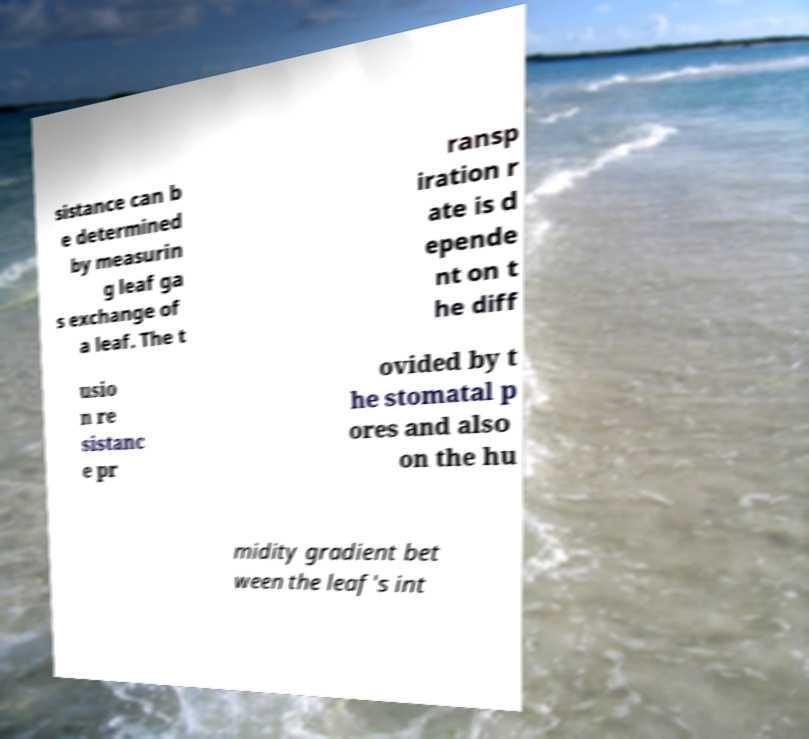For documentation purposes, I need the text within this image transcribed. Could you provide that? sistance can b e determined by measurin g leaf ga s exchange of a leaf. The t ransp iration r ate is d epende nt on t he diff usio n re sistanc e pr ovided by t he stomatal p ores and also on the hu midity gradient bet ween the leaf's int 